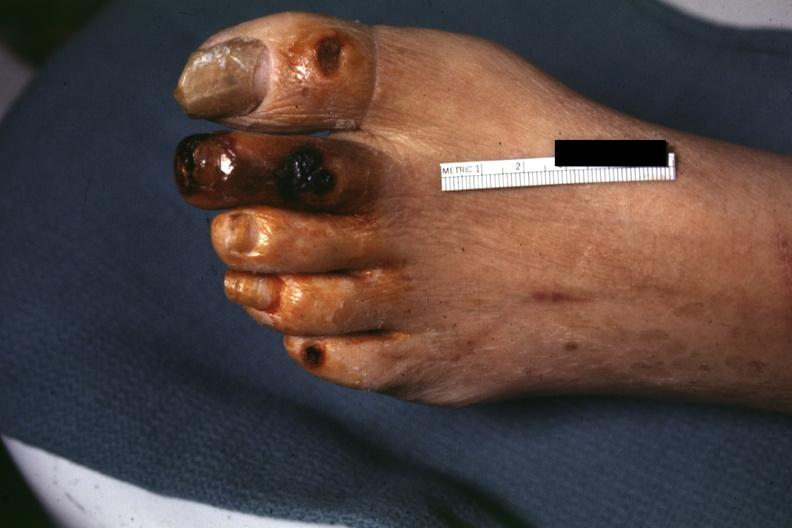s foot present?
Answer the question using a single word or phrase. Yes 